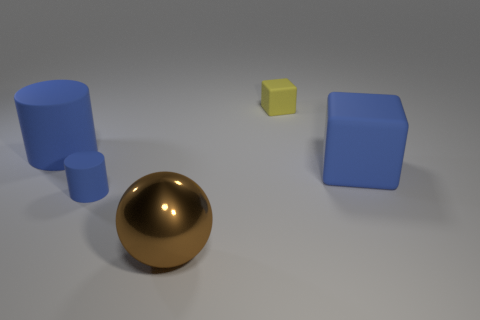Add 5 big cyan spheres. How many objects exist? 10 Subtract all cubes. How many objects are left? 3 Subtract all green shiny spheres. Subtract all tiny blocks. How many objects are left? 4 Add 1 balls. How many balls are left? 2 Add 1 big gray cubes. How many big gray cubes exist? 1 Subtract 0 red spheres. How many objects are left? 5 